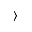<formula> <loc_0><loc_0><loc_500><loc_500>\rangle</formula> 